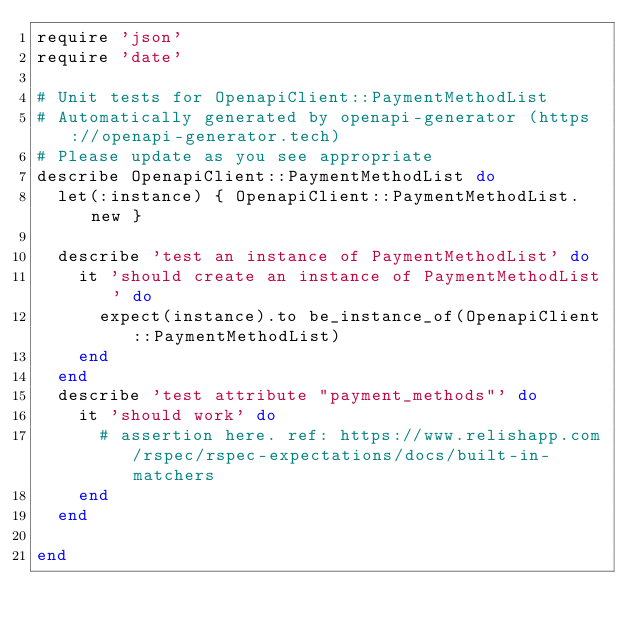<code> <loc_0><loc_0><loc_500><loc_500><_Ruby_>require 'json'
require 'date'

# Unit tests for OpenapiClient::PaymentMethodList
# Automatically generated by openapi-generator (https://openapi-generator.tech)
# Please update as you see appropriate
describe OpenapiClient::PaymentMethodList do
  let(:instance) { OpenapiClient::PaymentMethodList.new }

  describe 'test an instance of PaymentMethodList' do
    it 'should create an instance of PaymentMethodList' do
      expect(instance).to be_instance_of(OpenapiClient::PaymentMethodList)
    end
  end
  describe 'test attribute "payment_methods"' do
    it 'should work' do
      # assertion here. ref: https://www.relishapp.com/rspec/rspec-expectations/docs/built-in-matchers
    end
  end

end
</code> 